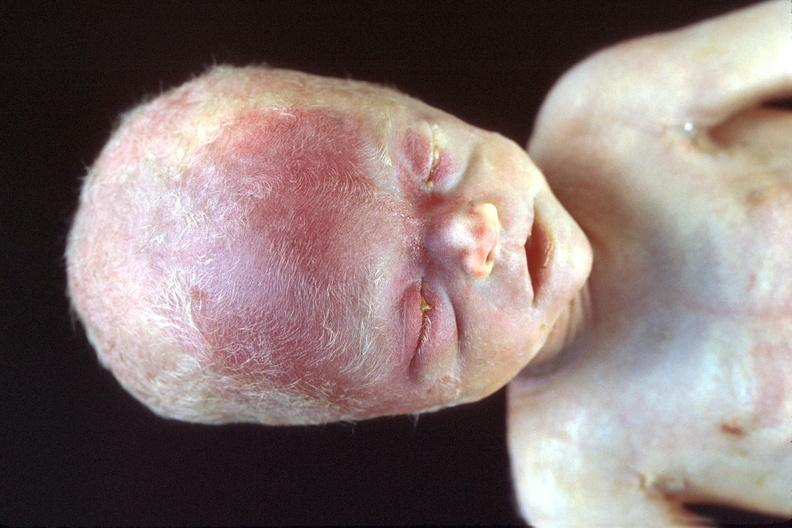does carcinoma show hyaline membrane disease?
Answer the question using a single word or phrase. No 